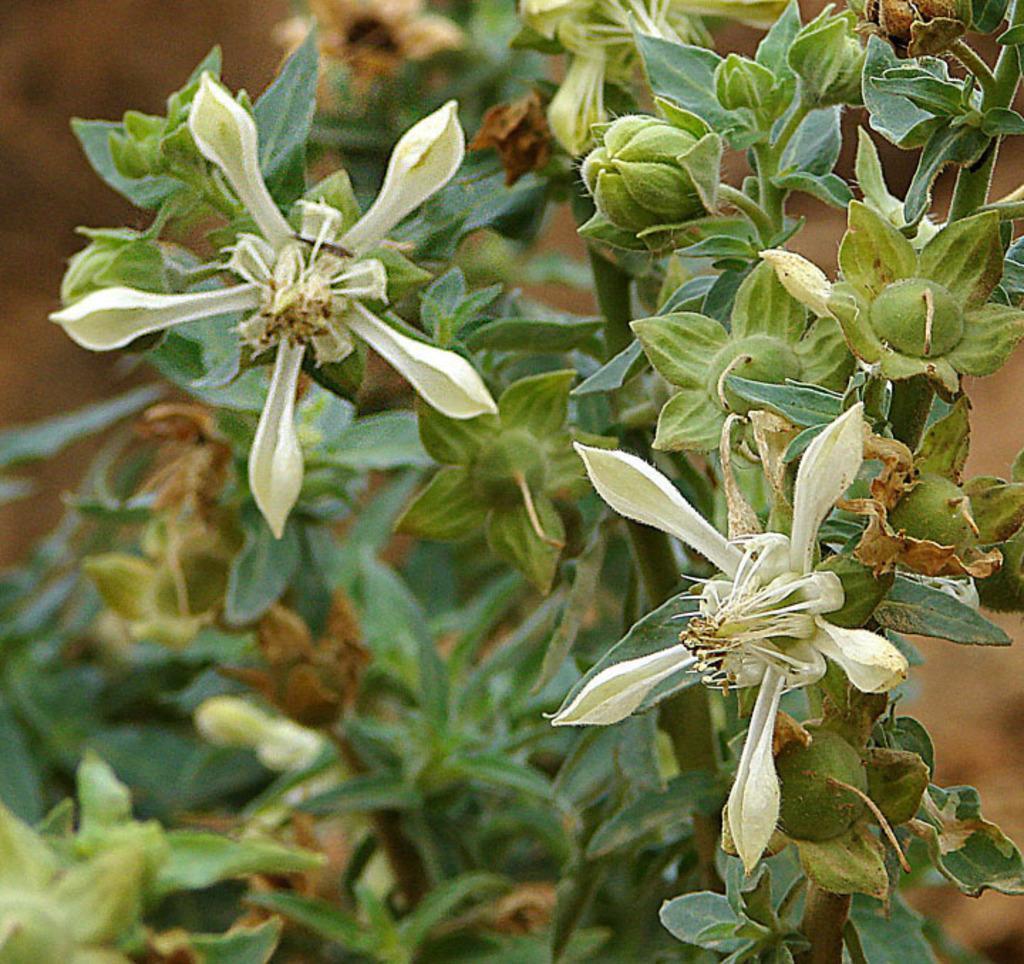How would you summarize this image in a sentence or two? We can see plant, flowers and buds. In the background it is blur. 